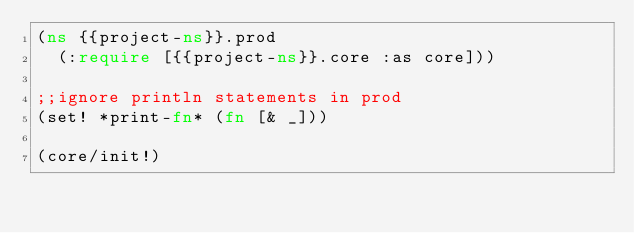<code> <loc_0><loc_0><loc_500><loc_500><_Clojure_>(ns {{project-ns}}.prod
  (:require [{{project-ns}}.core :as core]))

;;ignore println statements in prod
(set! *print-fn* (fn [& _]))

(core/init!)
</code> 